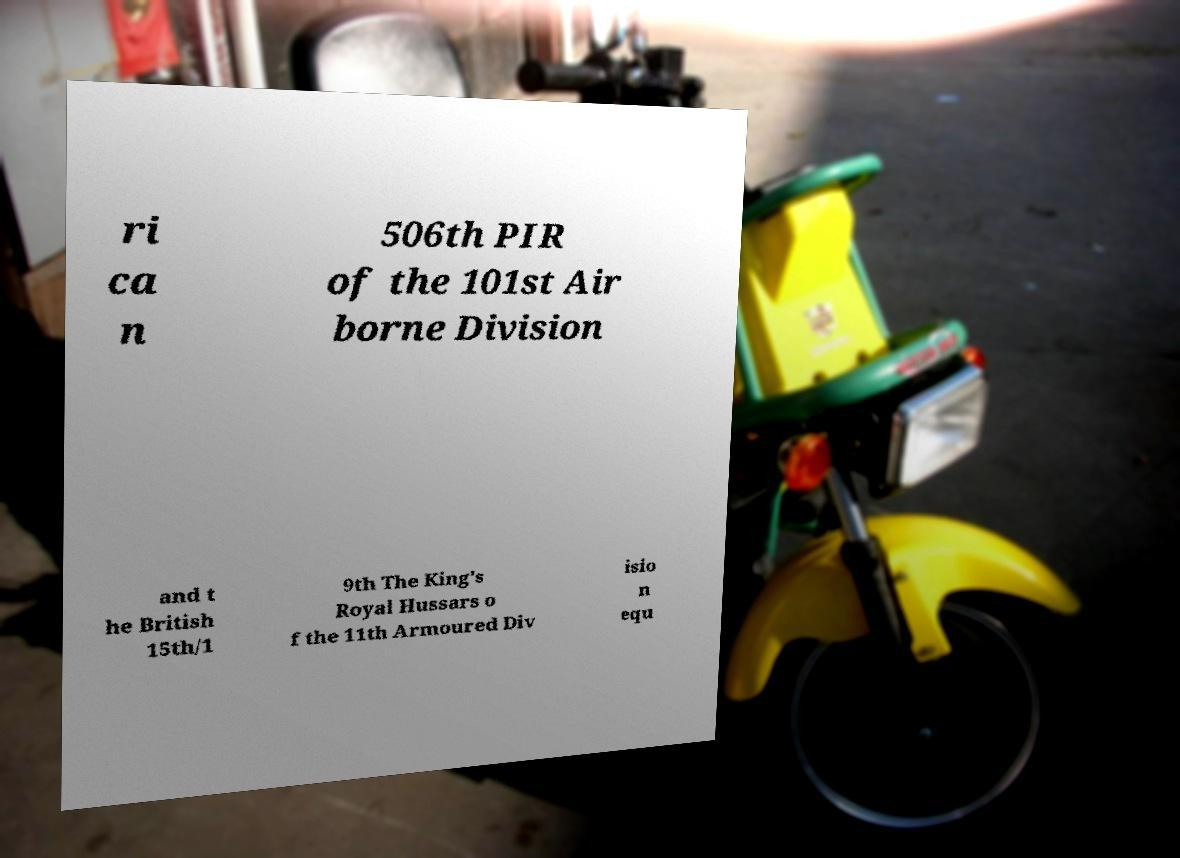Can you accurately transcribe the text from the provided image for me? ri ca n 506th PIR of the 101st Air borne Division and t he British 15th/1 9th The King's Royal Hussars o f the 11th Armoured Div isio n equ 